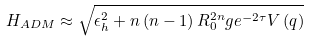Convert formula to latex. <formula><loc_0><loc_0><loc_500><loc_500>H _ { A D M } \approx \sqrt { \epsilon _ { h } ^ { 2 } + n \left ( n - 1 \right ) R _ { 0 } ^ { 2 n } g e ^ { - 2 \tau } V \left ( q \right ) }</formula> 